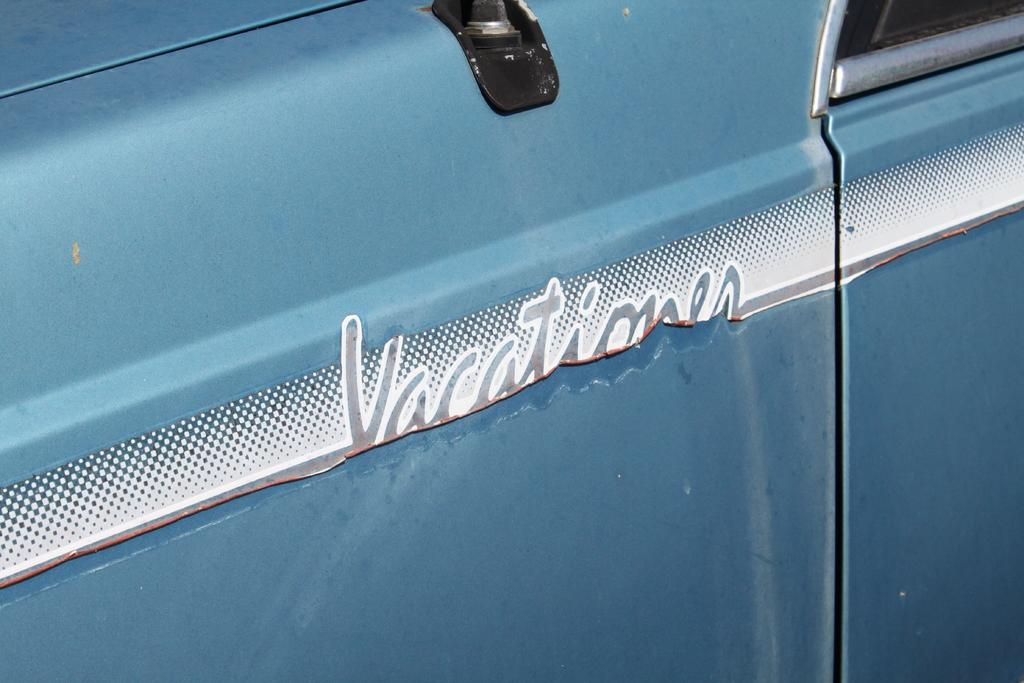What is the main subject of the image? The main subject of the image is a vehicle's body. Is there any text present in the image? Yes, there is text in the center of the image. What color is the vehicle in the image? The vehicle is blue in color. How many babies are sitting on the tree in the image? There is no tree or babies present in the image. 